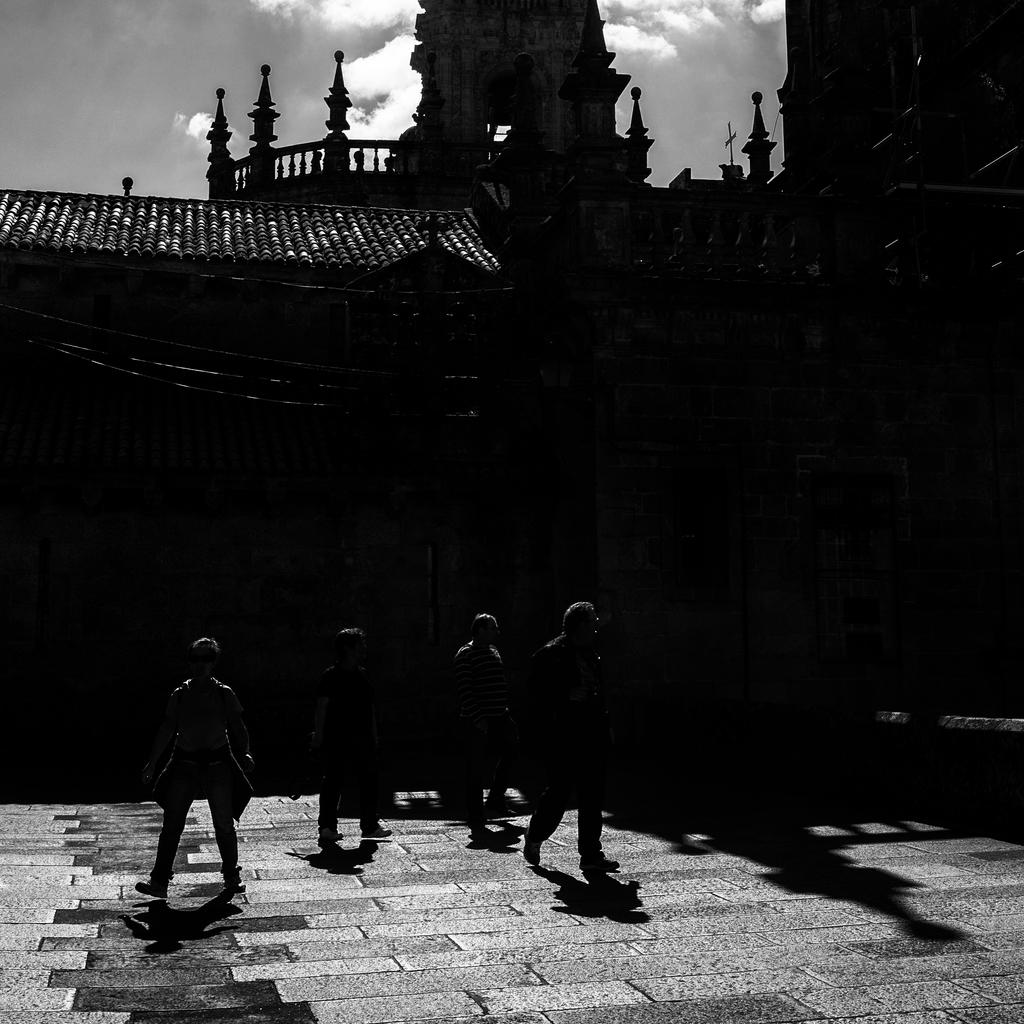How many people are in the image? There is a group of people in the image. What are the people doing in the image? The people are walking on a platform. What can be seen in the background of the image? There is a house in the background of the image. What architectural features are present on the house? The house has railings and pillars. What is visible at the top of the image? The sky is visible at the top of the image. What type of sponge is being used to clean the oven in the image? There is no sponge or oven present in the image. Is there a veil covering the house in the image? There is no veil visible in the image; the house has railings and pillars. 